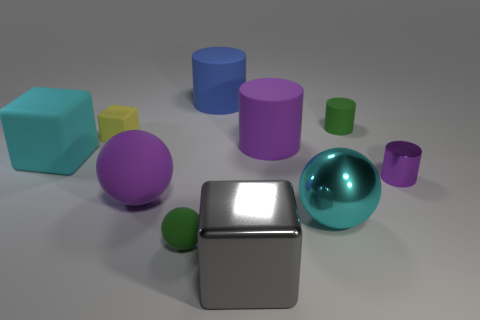What is the big blue object made of?
Make the answer very short. Rubber. There is a object that is both on the right side of the green sphere and in front of the large cyan metallic thing; what is its size?
Offer a very short reply. Large. What is the material of the small cylinder that is the same color as the tiny matte ball?
Your answer should be very brief. Rubber. How many yellow matte things are there?
Your answer should be compact. 1. Are there fewer tiny purple cylinders than tiny red shiny objects?
Provide a short and direct response. No. There is a blue thing that is the same size as the purple matte ball; what material is it?
Give a very brief answer. Rubber. How many things are either small rubber cubes or big brown metallic cubes?
Make the answer very short. 1. How many big objects are in front of the big cyan metal thing and on the left side of the tiny yellow thing?
Give a very brief answer. 0. Is the number of purple rubber things on the left side of the blue rubber object less than the number of green rubber objects?
Your response must be concise. Yes. There is another shiny thing that is the same size as the yellow object; what shape is it?
Your response must be concise. Cylinder. 